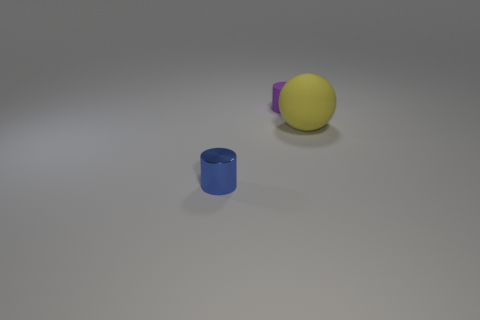Is there anything else that is the same shape as the purple thing?
Make the answer very short. Yes. The other tiny object that is the same shape as the purple thing is what color?
Provide a succinct answer. Blue. The small cylinder that is the same material as the yellow sphere is what color?
Offer a very short reply. Purple. Is the number of yellow rubber balls behind the large yellow rubber thing the same as the number of small purple matte objects?
Offer a very short reply. No. Does the object behind the ball have the same size as the tiny blue cylinder?
Your answer should be compact. Yes. There is a matte cylinder that is the same size as the blue metallic cylinder; what is its color?
Ensure brevity in your answer.  Purple. There is a thing left of the tiny object behind the tiny blue object; are there any purple matte things right of it?
Give a very brief answer. Yes. What is the small cylinder that is in front of the purple rubber object made of?
Offer a terse response. Metal. Do the blue object and the tiny thing that is to the right of the small blue metal thing have the same shape?
Ensure brevity in your answer.  Yes. Is the number of large yellow rubber things that are in front of the rubber ball the same as the number of purple rubber things right of the small rubber cylinder?
Your answer should be compact. Yes. 